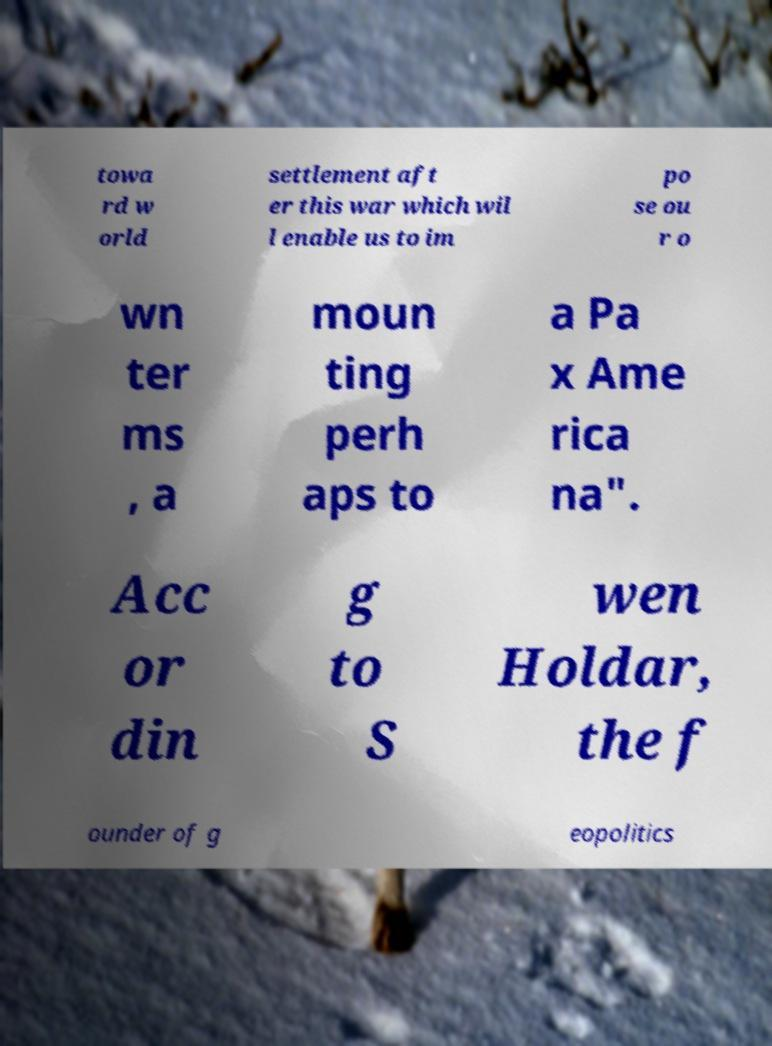I need the written content from this picture converted into text. Can you do that? towa rd w orld settlement aft er this war which wil l enable us to im po se ou r o wn ter ms , a moun ting perh aps to a Pa x Ame rica na". Acc or din g to S wen Holdar, the f ounder of g eopolitics 